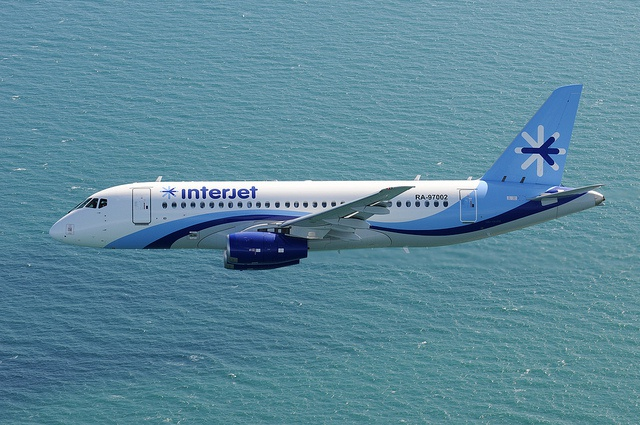Describe the objects in this image and their specific colors. I can see a airplane in gray, white, and darkgray tones in this image. 